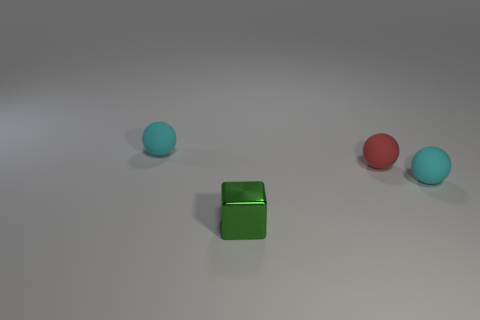Subtract all small red spheres. How many spheres are left? 2 Add 4 brown rubber cylinders. How many objects exist? 8 Subtract 2 balls. How many balls are left? 1 Subtract all cyan balls. How many balls are left? 1 Subtract all yellow spheres. Subtract all cyan cylinders. How many spheres are left? 3 Subtract all balls. How many objects are left? 1 Subtract all purple blocks. How many cyan spheres are left? 2 Subtract all small gray cylinders. Subtract all red spheres. How many objects are left? 3 Add 1 shiny things. How many shiny things are left? 2 Add 3 green cubes. How many green cubes exist? 4 